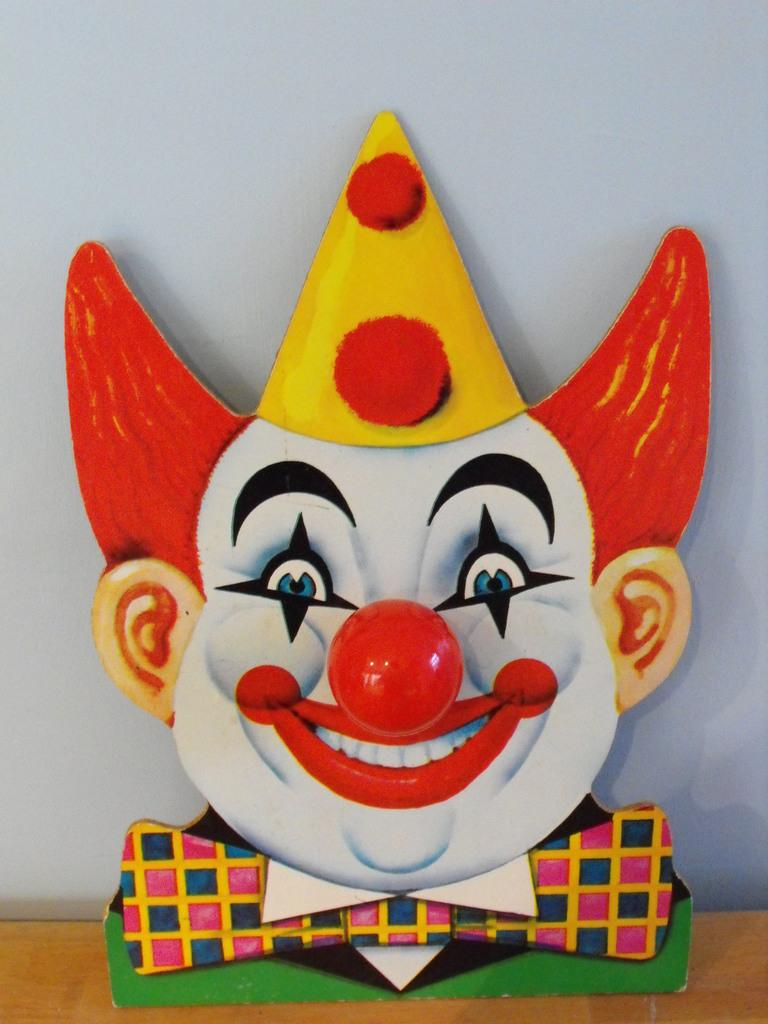What is the main subject of the image? The main subject of the image is a clown face. What colors are used to depict the clown face? The clown face is in white and red colors. Where is the clown face placed in the image? The clown face is placed on a brown desk. What can be seen in the background of the image? There is a wall in the background of the image. What type of weather can be seen in the image? There is no weather depicted in the image, as it features a clown face on a brown desk with a wall in the background. 